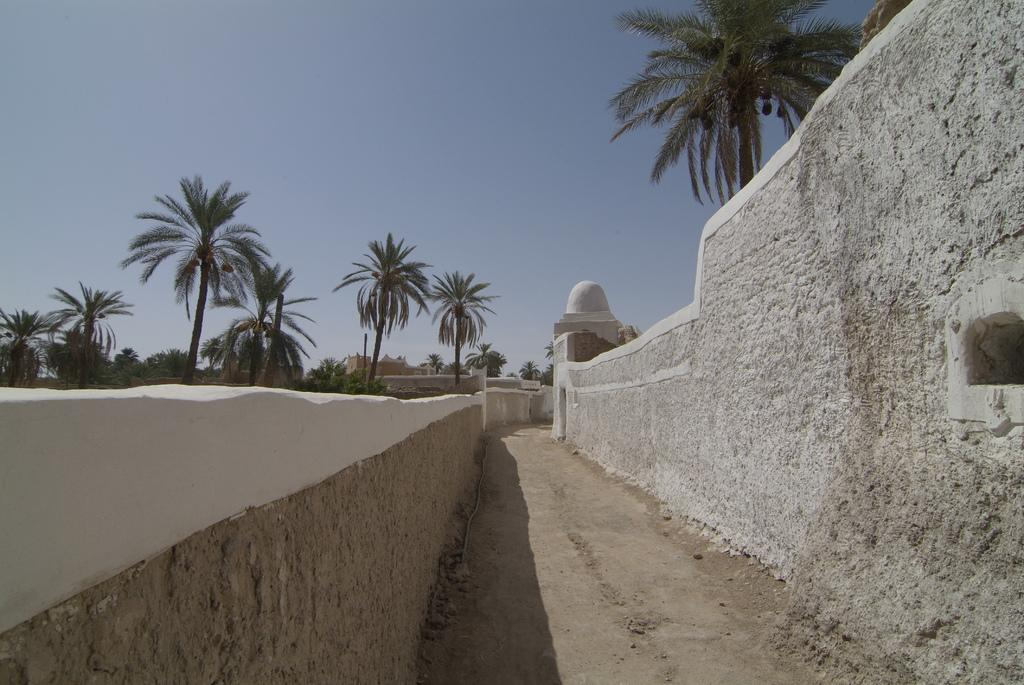What is the main structure visible in the image? There is a building in the image. What can be seen behind the building? There are many trees behind the building. What type of liquid is being poured from the flag in the image? There is no flag or liquid present in the image. 